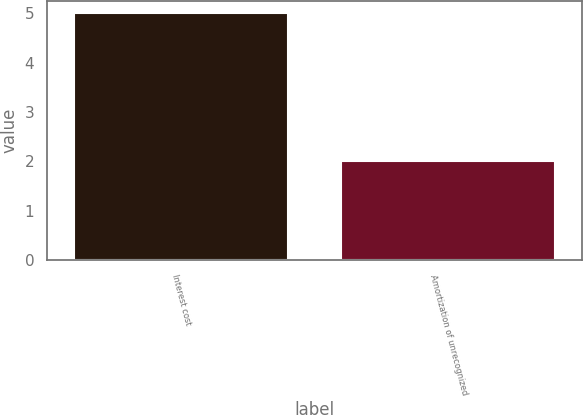<chart> <loc_0><loc_0><loc_500><loc_500><bar_chart><fcel>Interest cost<fcel>Amortization of unrecognized<nl><fcel>5<fcel>2<nl></chart> 